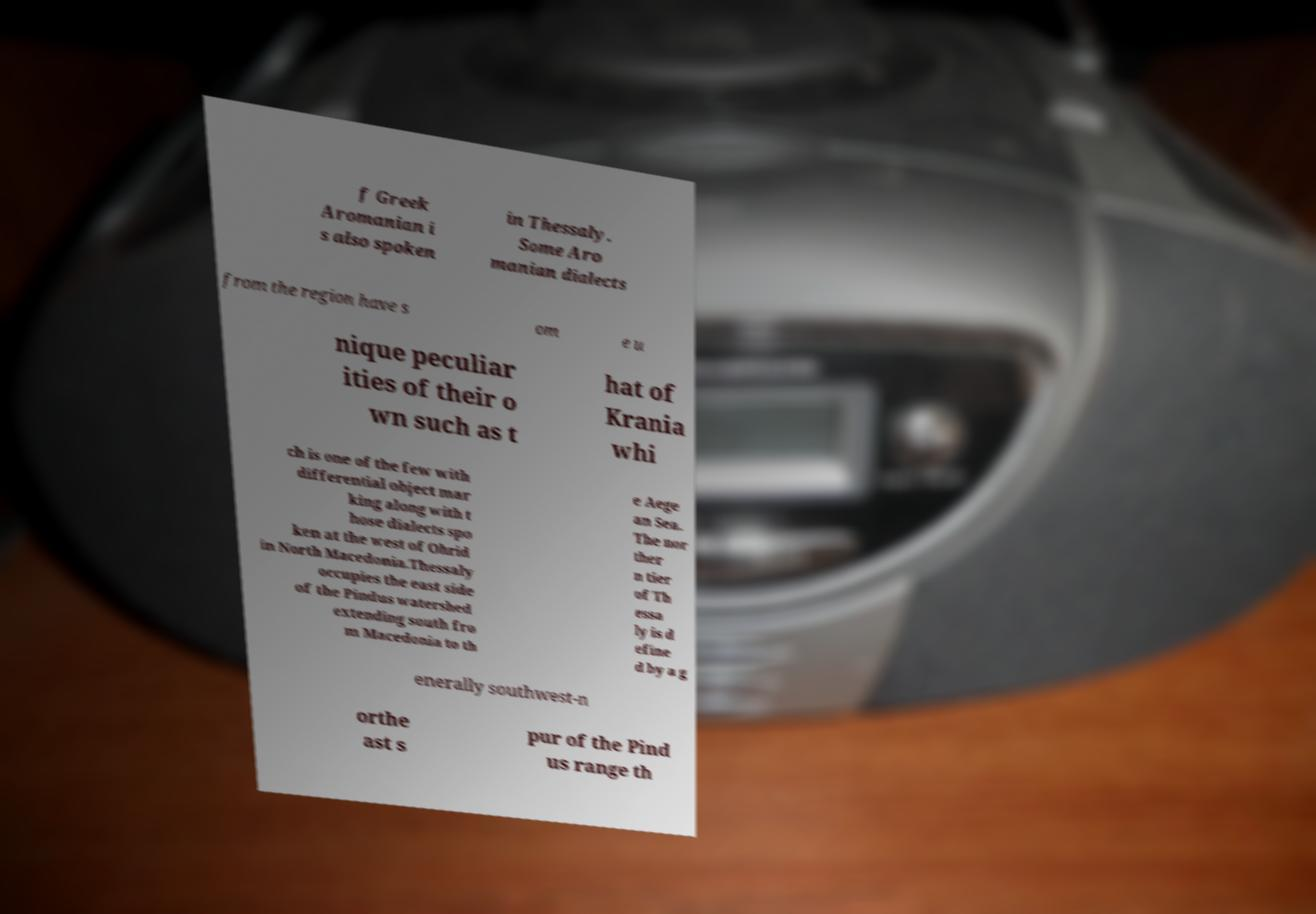I need the written content from this picture converted into text. Can you do that? f Greek Aromanian i s also spoken in Thessaly. Some Aro manian dialects from the region have s om e u nique peculiar ities of their o wn such as t hat of Krania whi ch is one of the few with differential object mar king along with t hose dialects spo ken at the west of Ohrid in North Macedonia.Thessaly occupies the east side of the Pindus watershed extending south fro m Macedonia to th e Aege an Sea. The nor ther n tier of Th essa ly is d efine d by a g enerally southwest-n orthe ast s pur of the Pind us range th 